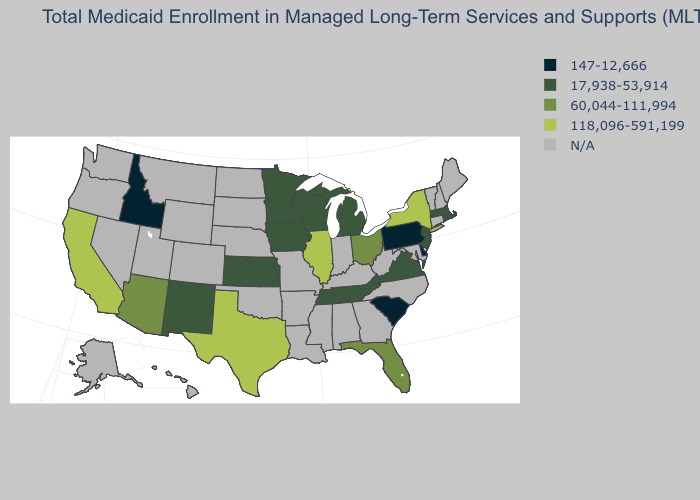What is the value of New Mexico?
Quick response, please. 17,938-53,914. Name the states that have a value in the range 147-12,666?
Write a very short answer. Delaware, Idaho, Pennsylvania, South Carolina. Does New York have the highest value in the USA?
Short answer required. Yes. What is the value of Virginia?
Short answer required. 17,938-53,914. Does Pennsylvania have the lowest value in the USA?
Answer briefly. Yes. Name the states that have a value in the range N/A?
Concise answer only. Alabama, Alaska, Arkansas, Colorado, Connecticut, Georgia, Hawaii, Indiana, Kentucky, Louisiana, Maine, Maryland, Mississippi, Missouri, Montana, Nebraska, Nevada, New Hampshire, North Carolina, North Dakota, Oklahoma, Oregon, South Dakota, Utah, Vermont, Washington, West Virginia, Wyoming. What is the highest value in states that border Texas?
Write a very short answer. 17,938-53,914. What is the value of Oklahoma?
Answer briefly. N/A. What is the value of Ohio?
Answer briefly. 60,044-111,994. How many symbols are there in the legend?
Write a very short answer. 5. Is the legend a continuous bar?
Concise answer only. No. Among the states that border Missouri , does Illinois have the lowest value?
Write a very short answer. No. Does Tennessee have the highest value in the South?
Keep it brief. No. 